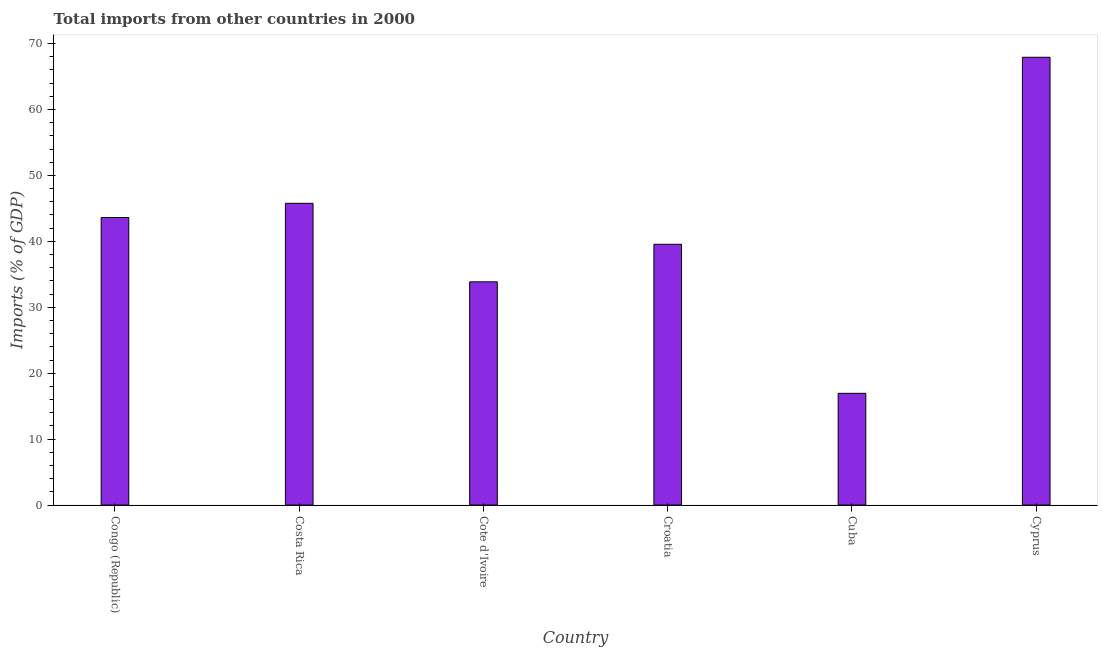What is the title of the graph?
Offer a terse response. Total imports from other countries in 2000. What is the label or title of the X-axis?
Make the answer very short. Country. What is the label or title of the Y-axis?
Provide a succinct answer. Imports (% of GDP). What is the total imports in Croatia?
Your response must be concise. 39.55. Across all countries, what is the maximum total imports?
Provide a succinct answer. 67.91. Across all countries, what is the minimum total imports?
Offer a very short reply. 16.95. In which country was the total imports maximum?
Make the answer very short. Cyprus. In which country was the total imports minimum?
Give a very brief answer. Cuba. What is the sum of the total imports?
Provide a succinct answer. 247.65. What is the difference between the total imports in Costa Rica and Cuba?
Ensure brevity in your answer.  28.82. What is the average total imports per country?
Make the answer very short. 41.27. What is the median total imports?
Ensure brevity in your answer.  41.58. What is the ratio of the total imports in Congo (Republic) to that in Cyprus?
Provide a short and direct response. 0.64. What is the difference between the highest and the second highest total imports?
Your response must be concise. 22.15. What is the difference between the highest and the lowest total imports?
Ensure brevity in your answer.  50.97. In how many countries, is the total imports greater than the average total imports taken over all countries?
Your answer should be very brief. 3. How many countries are there in the graph?
Your answer should be very brief. 6. What is the Imports (% of GDP) in Congo (Republic)?
Provide a short and direct response. 43.61. What is the Imports (% of GDP) of Costa Rica?
Make the answer very short. 45.77. What is the Imports (% of GDP) in Cote d'Ivoire?
Provide a succinct answer. 33.86. What is the Imports (% of GDP) of Croatia?
Offer a terse response. 39.55. What is the Imports (% of GDP) of Cuba?
Keep it short and to the point. 16.95. What is the Imports (% of GDP) in Cyprus?
Ensure brevity in your answer.  67.91. What is the difference between the Imports (% of GDP) in Congo (Republic) and Costa Rica?
Your answer should be compact. -2.15. What is the difference between the Imports (% of GDP) in Congo (Republic) and Cote d'Ivoire?
Ensure brevity in your answer.  9.76. What is the difference between the Imports (% of GDP) in Congo (Republic) and Croatia?
Your answer should be very brief. 4.06. What is the difference between the Imports (% of GDP) in Congo (Republic) and Cuba?
Offer a very short reply. 26.67. What is the difference between the Imports (% of GDP) in Congo (Republic) and Cyprus?
Keep it short and to the point. -24.3. What is the difference between the Imports (% of GDP) in Costa Rica and Cote d'Ivoire?
Make the answer very short. 11.91. What is the difference between the Imports (% of GDP) in Costa Rica and Croatia?
Offer a very short reply. 6.21. What is the difference between the Imports (% of GDP) in Costa Rica and Cuba?
Provide a short and direct response. 28.82. What is the difference between the Imports (% of GDP) in Costa Rica and Cyprus?
Your response must be concise. -22.15. What is the difference between the Imports (% of GDP) in Cote d'Ivoire and Croatia?
Offer a terse response. -5.7. What is the difference between the Imports (% of GDP) in Cote d'Ivoire and Cuba?
Make the answer very short. 16.91. What is the difference between the Imports (% of GDP) in Cote d'Ivoire and Cyprus?
Your answer should be very brief. -34.06. What is the difference between the Imports (% of GDP) in Croatia and Cuba?
Give a very brief answer. 22.61. What is the difference between the Imports (% of GDP) in Croatia and Cyprus?
Ensure brevity in your answer.  -28.36. What is the difference between the Imports (% of GDP) in Cuba and Cyprus?
Make the answer very short. -50.97. What is the ratio of the Imports (% of GDP) in Congo (Republic) to that in Costa Rica?
Offer a very short reply. 0.95. What is the ratio of the Imports (% of GDP) in Congo (Republic) to that in Cote d'Ivoire?
Ensure brevity in your answer.  1.29. What is the ratio of the Imports (% of GDP) in Congo (Republic) to that in Croatia?
Offer a very short reply. 1.1. What is the ratio of the Imports (% of GDP) in Congo (Republic) to that in Cuba?
Your answer should be compact. 2.57. What is the ratio of the Imports (% of GDP) in Congo (Republic) to that in Cyprus?
Ensure brevity in your answer.  0.64. What is the ratio of the Imports (% of GDP) in Costa Rica to that in Cote d'Ivoire?
Provide a short and direct response. 1.35. What is the ratio of the Imports (% of GDP) in Costa Rica to that in Croatia?
Your answer should be compact. 1.16. What is the ratio of the Imports (% of GDP) in Costa Rica to that in Cuba?
Your response must be concise. 2.7. What is the ratio of the Imports (% of GDP) in Costa Rica to that in Cyprus?
Your answer should be very brief. 0.67. What is the ratio of the Imports (% of GDP) in Cote d'Ivoire to that in Croatia?
Provide a succinct answer. 0.86. What is the ratio of the Imports (% of GDP) in Cote d'Ivoire to that in Cuba?
Keep it short and to the point. 2. What is the ratio of the Imports (% of GDP) in Cote d'Ivoire to that in Cyprus?
Your response must be concise. 0.5. What is the ratio of the Imports (% of GDP) in Croatia to that in Cuba?
Offer a very short reply. 2.33. What is the ratio of the Imports (% of GDP) in Croatia to that in Cyprus?
Make the answer very short. 0.58. What is the ratio of the Imports (% of GDP) in Cuba to that in Cyprus?
Ensure brevity in your answer.  0.25. 